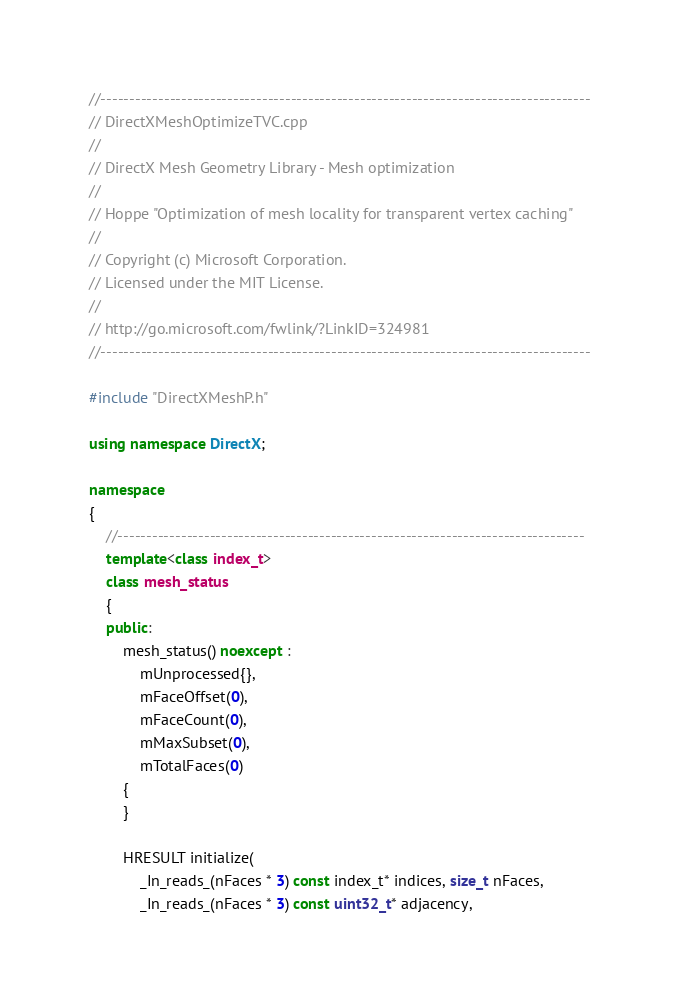<code> <loc_0><loc_0><loc_500><loc_500><_C++_>//-------------------------------------------------------------------------------------
// DirectXMeshOptimizeTVC.cpp
//
// DirectX Mesh Geometry Library - Mesh optimization
//
// Hoppe "Optimization of mesh locality for transparent vertex caching"
//
// Copyright (c) Microsoft Corporation.
// Licensed under the MIT License.
//
// http://go.microsoft.com/fwlink/?LinkID=324981
//-------------------------------------------------------------------------------------

#include "DirectXMeshP.h"

using namespace DirectX;

namespace
{
    //---------------------------------------------------------------------------------
    template<class index_t>
    class mesh_status
    {
    public:
        mesh_status() noexcept :
            mUnprocessed{},
            mFaceOffset(0),
            mFaceCount(0),
            mMaxSubset(0),
            mTotalFaces(0)
        {
        }

        HRESULT initialize(
            _In_reads_(nFaces * 3) const index_t* indices, size_t nFaces,
            _In_reads_(nFaces * 3) const uint32_t* adjacency,</code> 